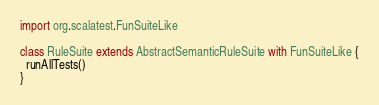Convert code to text. <code><loc_0><loc_0><loc_500><loc_500><_Scala_>import org.scalatest.FunSuiteLike

class RuleSuite extends AbstractSemanticRuleSuite with FunSuiteLike {
  runAllTests()
}
</code> 